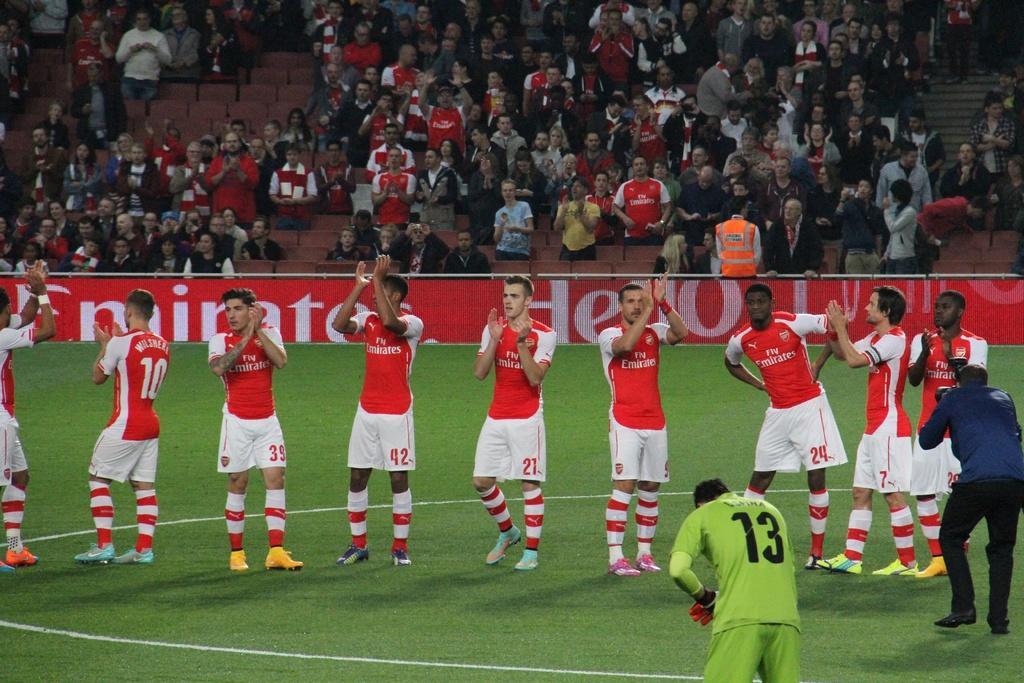Describe this image in one or two sentences. In the center of the image some persons are standing and some of them are clapping. At the top of the image we can see a group of people, board, chairs. In the background of the image ground is there. On the right side of the image a man is standing and holding camera in his hand. 